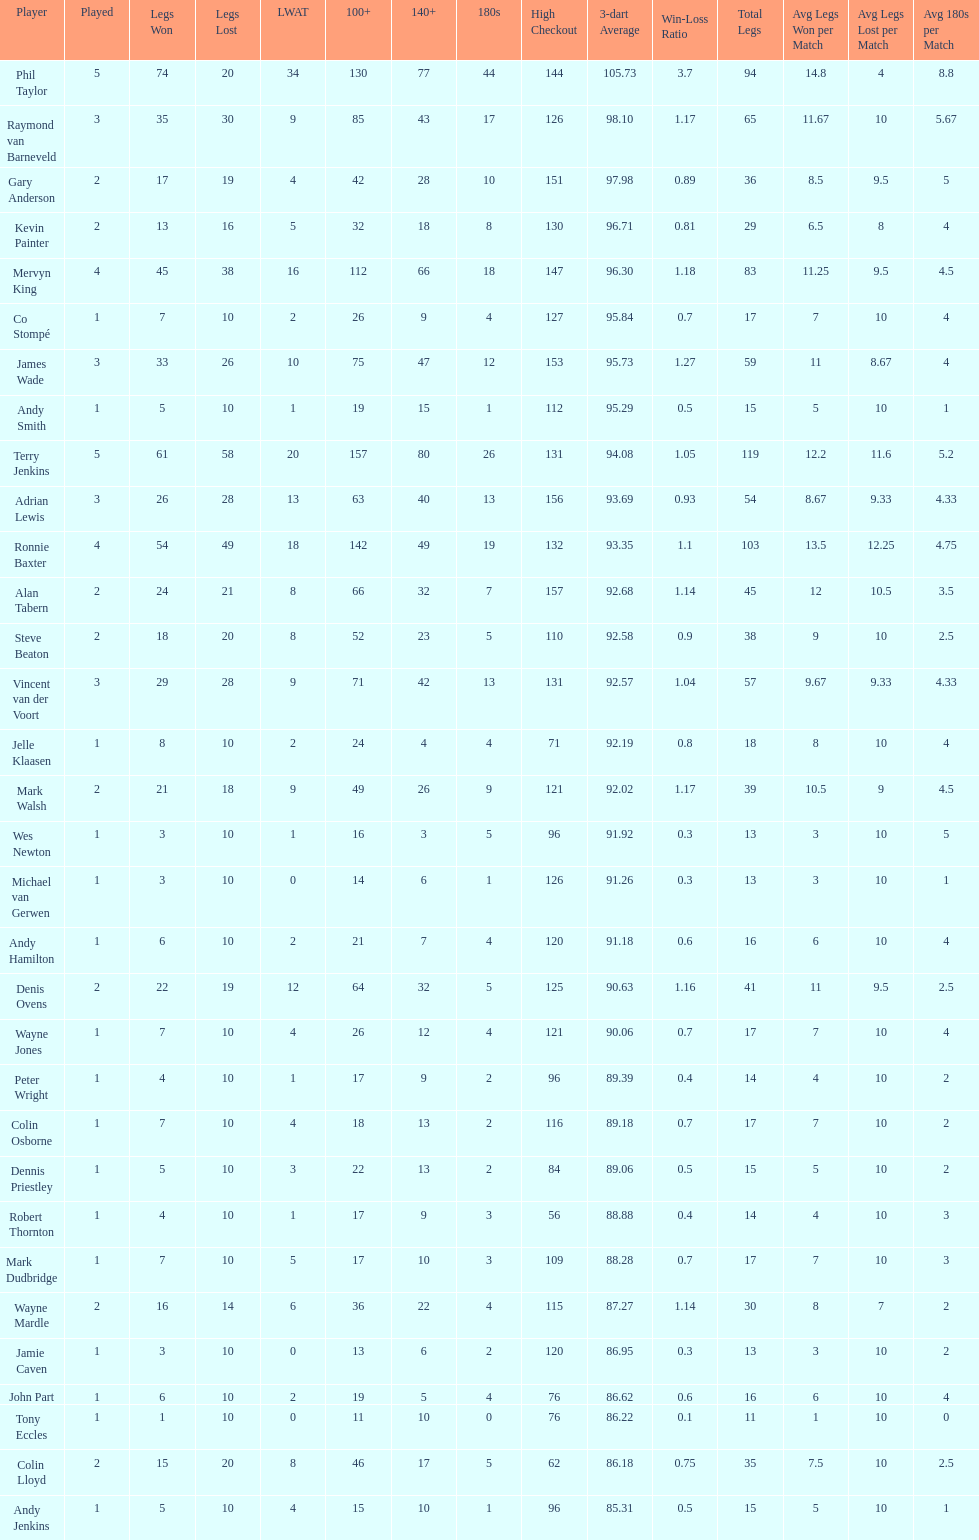What are the number of legs lost by james wade? 26. 